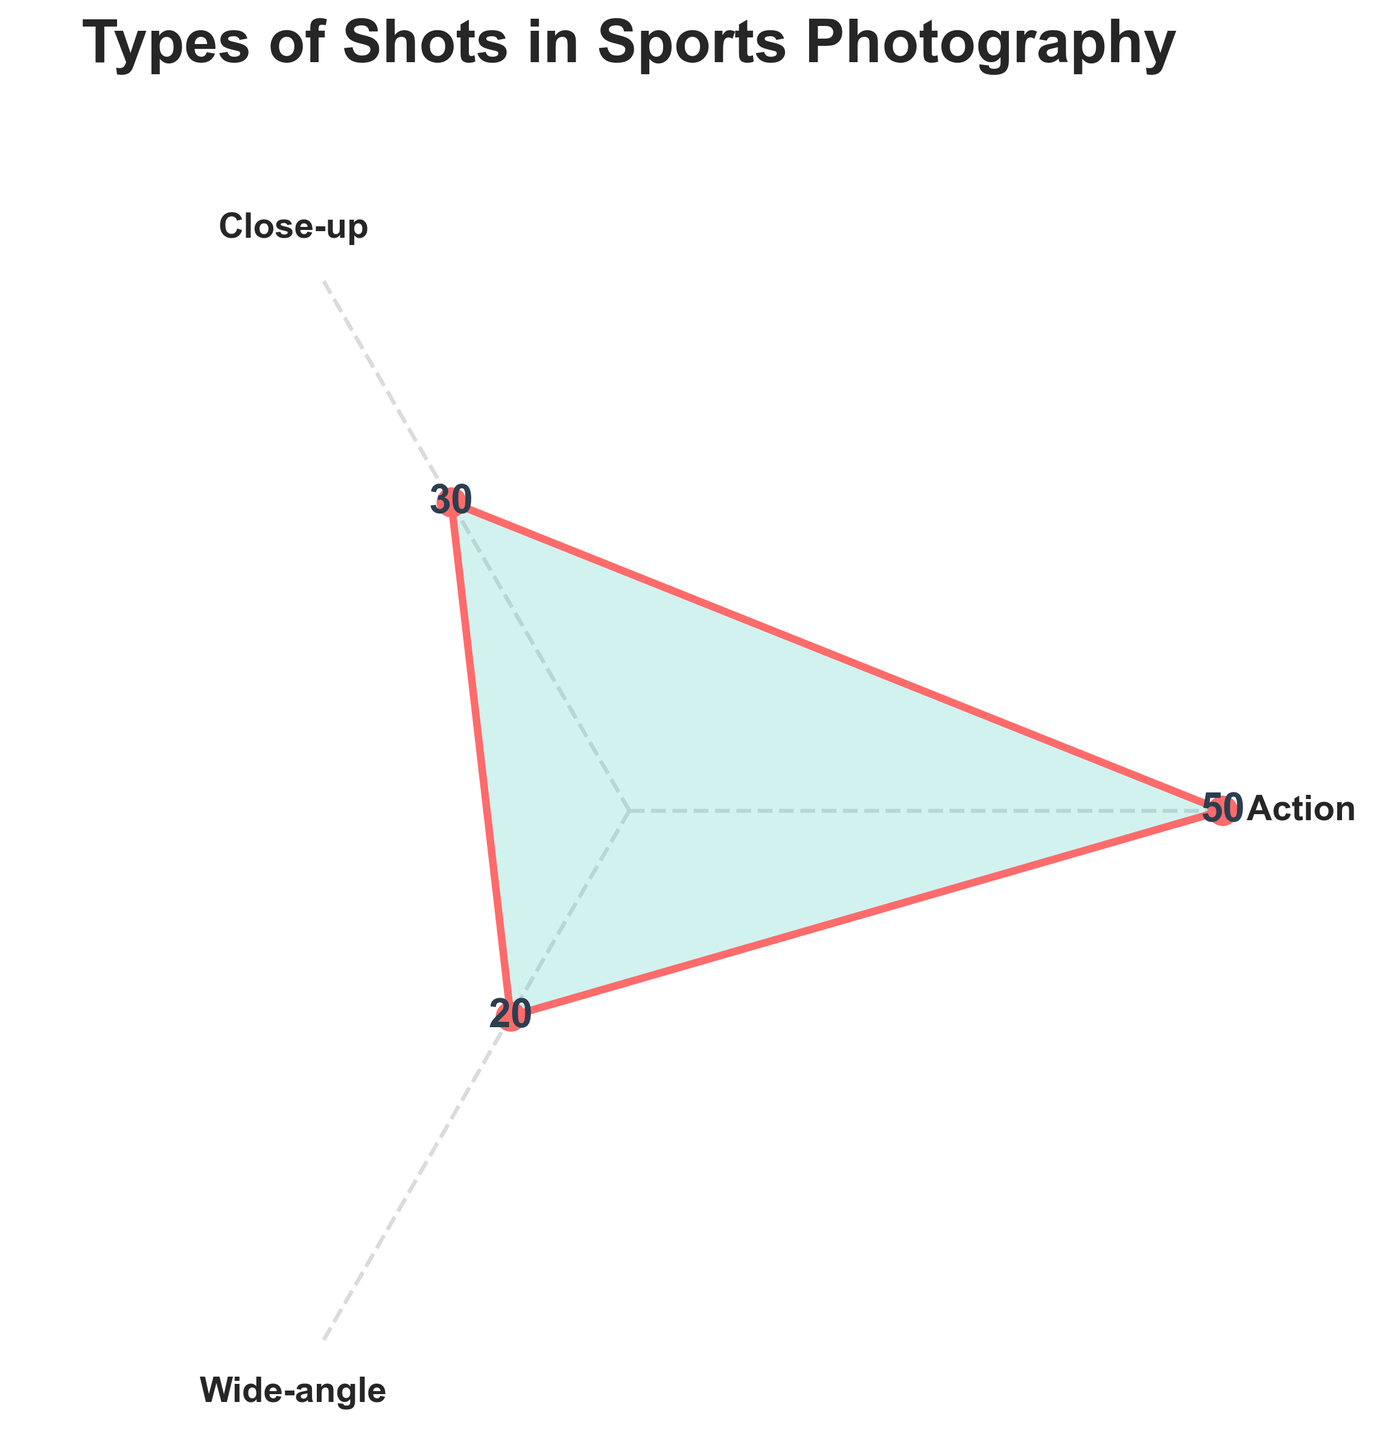What is the title of the rose chart? The title of the rose chart is found at the top of the figure in bold text. It states the theme of the chart.
Answer: "Types of Shots in Sports Photography" How many categories of shots are represented in the chart? By looking at the angular tick labels, we can count the number of unique categories of shots.
Answer: 3 Which type of shot has the highest count? By examining the data points and observing the highest value on the chart, we see that the count for "Action" is the highest.
Answer: Action What is the sum of counts for all types of shots? Add the counts of the Action, Close-up, and Wide-angle shots: 50 (Action) + 30 (Close-up) + 20 (Wide-angle) = 100.
Answer: 100 What is the difference in counts between Action shots and Wide-angle shots? Subtract the count of Wide-angle shots from the count of Action shots: 50 - 20 = 30.
Answer: 30 Which type of shot has the least representation on the chart? By identifying the smallest value on the chart, we see that Wide-angle has the smallest count.
Answer: Wide-angle What is the average count of all the types of shots represented? Calculate the average by summing the counts (50 + 30 + 20) and dividing by the number of types (3): (50 + 30 + 20) / 3 ≈ 33.33.
Answer: 33.33 How many more Close-up shots are there compared to Wide-angle shots? Subtract the count of Wide-angle shots from the count of Close-up shots: 30 - 20 = 10.
Answer: 10 Are there more Action shots than the total of Close-up and Wide-angle shots combined? Sum the counts of Close-up and Wide-angle shots and compare with Action shots: 30 (Close-up) + 20 (Wide-angle) = 50. The count for Action shots is also 50.
Answer: No What is the ratio of Action shots to the total number of shots? Divide the count of Action shots by the total number of shots: 50 / (50 + 30 + 20) = 50 / 100 = 0.5.
Answer: 0.5 